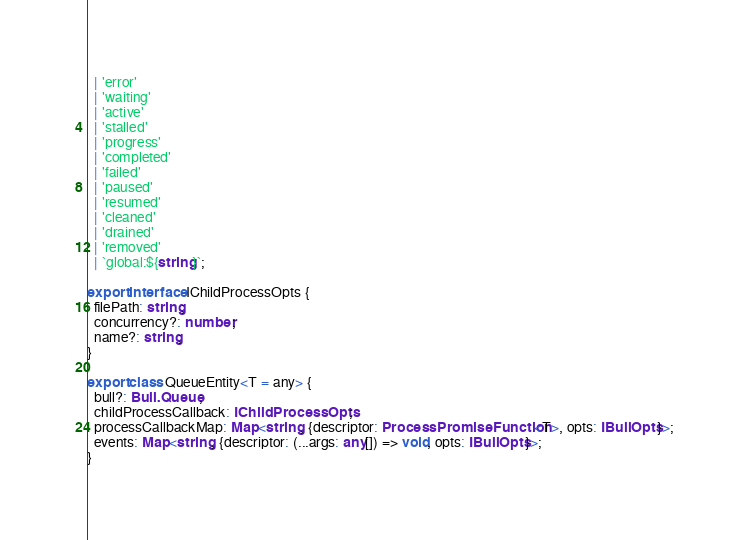<code> <loc_0><loc_0><loc_500><loc_500><_TypeScript_>  | 'error'
  | 'waiting'
  | 'active'
  | 'stalled'
  | 'progress'
  | 'completed'
  | 'failed'
  | 'paused'
  | 'resumed'
  | 'cleaned'
  | 'drained'
  | 'removed'
  | `global:${string}`;

export interface IChildProcessOpts {
  filePath: string;
  concurrency?: number;
  name?: string;
}

export class QueueEntity<T = any> {
  bull?: Bull.Queue;
  childProcessCallback: IChildProcessOpts;
  processCallbackMap: Map<string, {descriptor: ProcessPromiseFunction<T>, opts: IBullOpts}>;
  events: Map<string, {descriptor: (...args: any[]) => void, opts: IBullOpts}>;
}
</code> 